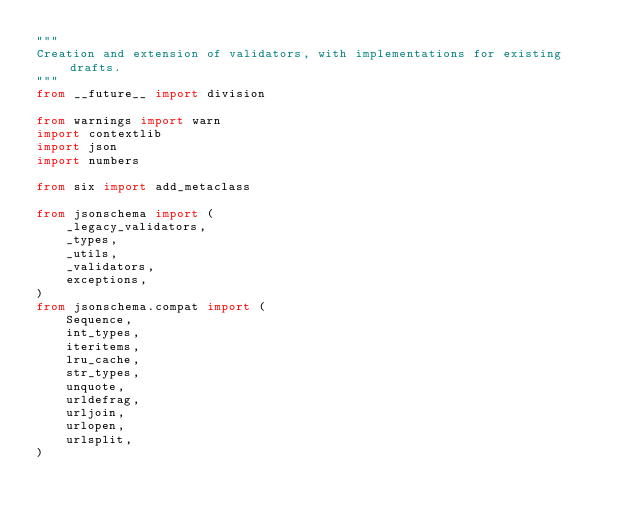<code> <loc_0><loc_0><loc_500><loc_500><_Python_>"""
Creation and extension of validators, with implementations for existing drafts.
"""
from __future__ import division

from warnings import warn
import contextlib
import json
import numbers

from six import add_metaclass

from jsonschema import (
    _legacy_validators,
    _types,
    _utils,
    _validators,
    exceptions,
)
from jsonschema.compat import (
    Sequence,
    int_types,
    iteritems,
    lru_cache,
    str_types,
    unquote,
    urldefrag,
    urljoin,
    urlopen,
    urlsplit,
)
</code> 